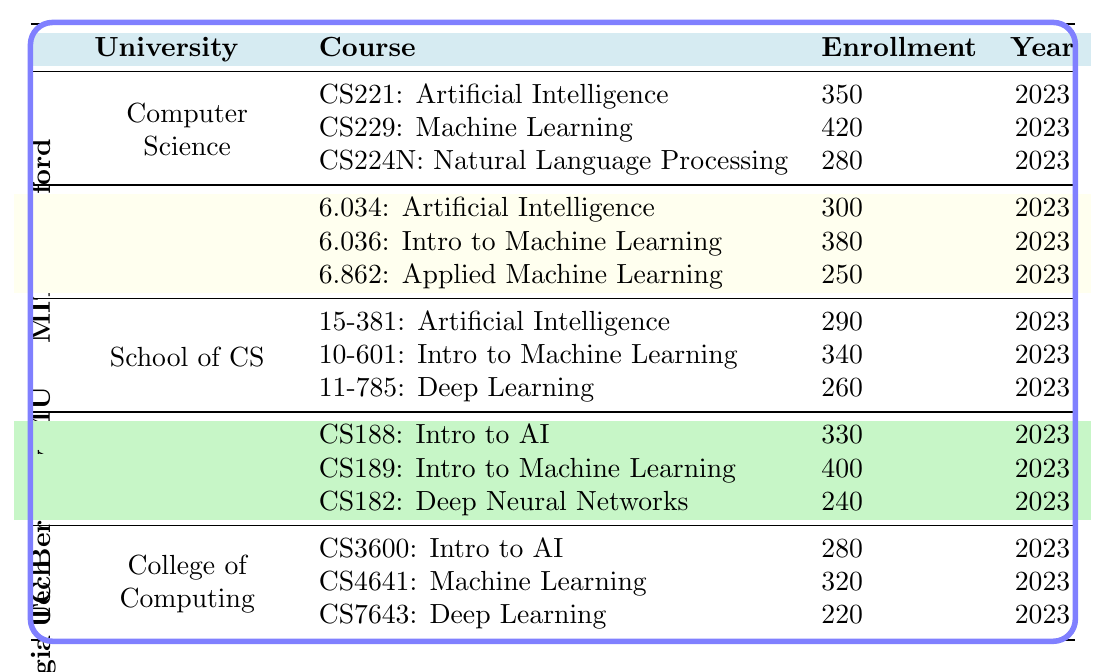What is the enrollment for CS229: Machine Learning at Stanford University? The table lists CS229: Machine Learning under Stanford University with an enrollment of 420 students in 2023.
Answer: 420 Which university has the highest enrollment for AI-related courses? Looking at the enrollments from all universities, Stanford University has the highest enrollment of 420 in CS229: Machine Learning.
Answer: Stanford University What is the total enrollment for AI-related courses at MIT in 2023? Adding the enrollment numbers for MIT: 300 (6.034) + 380 (6.036) + 250 (6.862) gives a total of 930 students.
Answer: 930 How many courses are offered by Carnegie Mellon University in the table? Carnegie Mellon University offers three courses: Artificial Intelligence, Introduction to Machine Learning, and Deep Learning.
Answer: 3 What is the difference in enrollment between the highest and lowest enrolled courses at UC Berkeley? The highest enrollment at UC Berkeley is 400 (CS189) and the lowest is 240 (CS182). The difference is 400 - 240 = 160.
Answer: 160 Are there any courses with an enrollment of more than 400 students? Yes, the course CS229: Machine Learning at Stanford has an enrollment of 420, which is more than 400.
Answer: Yes What is the average enrollment per course for Georgia Tech? The enrollments for Georgia Tech are 280 (CS3600), 320 (CS4641), and 220 (CS7643). The total is 280 + 320 + 220 = 820; thus, the average enrollment is 820 / 3 = 273.33.
Answer: 273.33 Which university has the lowest single course enrollment, and what is the enrollment number? By examining the courses, Georgia Institute of Technology has the lowest enrollment at 220 for CS7643: Deep Learning.
Answer: Georgia Institute of Technology, 220 What is the total enrollment for all AI-related courses across all universities? Summing up all the enrollments: 350 (Stanford) + 420 + 280 + 300 (MIT) + 380 + 250 + 290 (CMU) + 340 + 260 + 330 (UC Berkeley) + 400 + 240 + 280 (Georgia Tech) + 320 + 220 totals to 4,320.
Answer: 4,320 If you combine the enrollment for the two highest enrolling courses across all universities, what would that total be? The highest is 420 (CS229 at Stanford) and the second-highest is 400 (CS189 at UC Berkeley). So the total is 420 + 400 = 820.
Answer: 820 